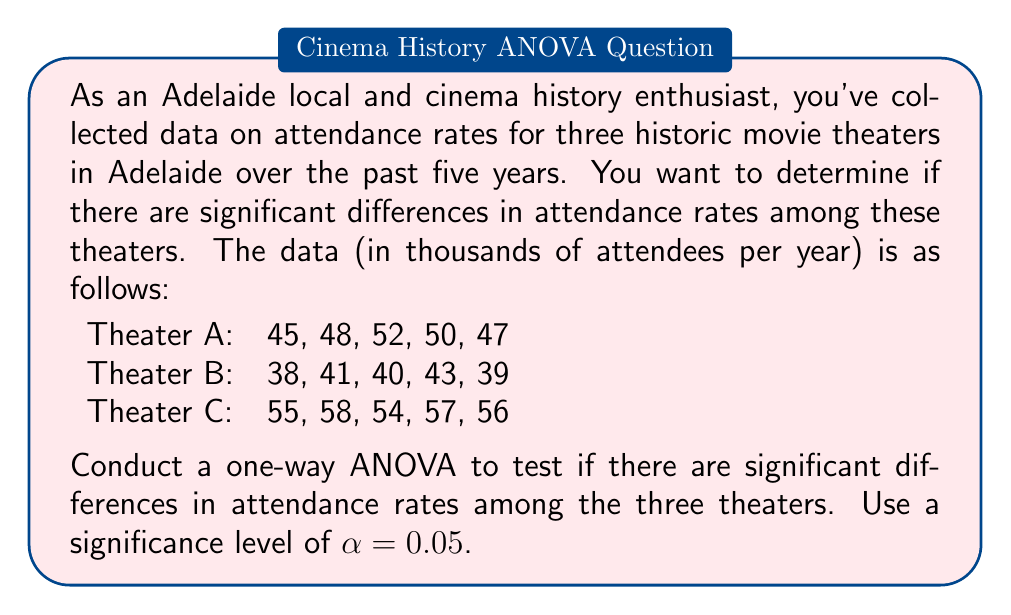Solve this math problem. To conduct a one-way ANOVA, we'll follow these steps:

1. Calculate the sum of squares between groups (SSB), within groups (SSW), and total (SST).
2. Calculate the degrees of freedom for between groups (dfB), within groups (dfW), and total (dfT).
3. Calculate the mean square between groups (MSB) and within groups (MSW).
4. Calculate the F-statistic.
5. Compare the F-statistic to the critical F-value.

Step 1: Calculate sum of squares

First, we need to calculate the grand mean:
$$ \bar{X} = \frac{45 + 48 + ... + 56}{15} = 48.2 $$

Now, we can calculate SSB, SSW, and SST:

SSB = $\sum_{i=1}^k n_i(\bar{X}_i - \bar{X})^2$
$$ SSB = 5[(48.4 - 48.2)^2 + (40.2 - 48.2)^2 + (56 - 48.2)^2] = 782.8 $$

SSW = $\sum_{i=1}^k \sum_{j=1}^{n_i} (X_{ij} - \bar{X}_i)^2$
$$ SSW = [(45-48.4)^2 + ... + (56-56)^2] = 122 $$

SST = SSB + SSW = 782.8 + 122 = 904.8

Step 2: Calculate degrees of freedom

dfB = k - 1 = 3 - 1 = 2
dfW = N - k = 15 - 3 = 12
dfT = N - 1 = 15 - 1 = 14

Step 3: Calculate mean squares

$$ MSB = \frac{SSB}{dfB} = \frac{782.8}{2} = 391.4 $$
$$ MSW = \frac{SSW}{dfW} = \frac{122}{12} = 10.17 $$

Step 4: Calculate F-statistic

$$ F = \frac{MSB}{MSW} = \frac{391.4}{10.17} = 38.49 $$

Step 5: Compare F-statistic to critical F-value

The critical F-value for α = 0.05, dfB = 2, and dfW = 12 is approximately 3.89.

Since our calculated F-statistic (38.49) is greater than the critical F-value (3.89), we reject the null hypothesis.
Answer: The one-way ANOVA results (F(2,12) = 38.49, p < 0.05) indicate that there are significant differences in attendance rates among the three historic movie theaters in Adelaide. 